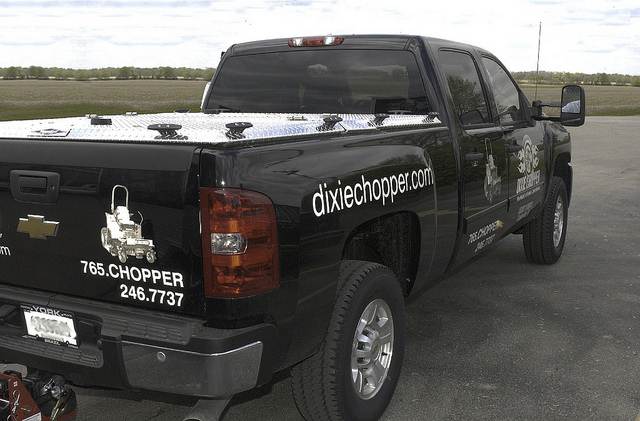<image>What state is the truck from? It is unknown what state the truck is from. It could be from New York, Indiana, Texas or Dixie. What state is the truck from? I am not sure which state the truck is from. It could be from New York, Dixie, Indiana, Texas or unknown. 